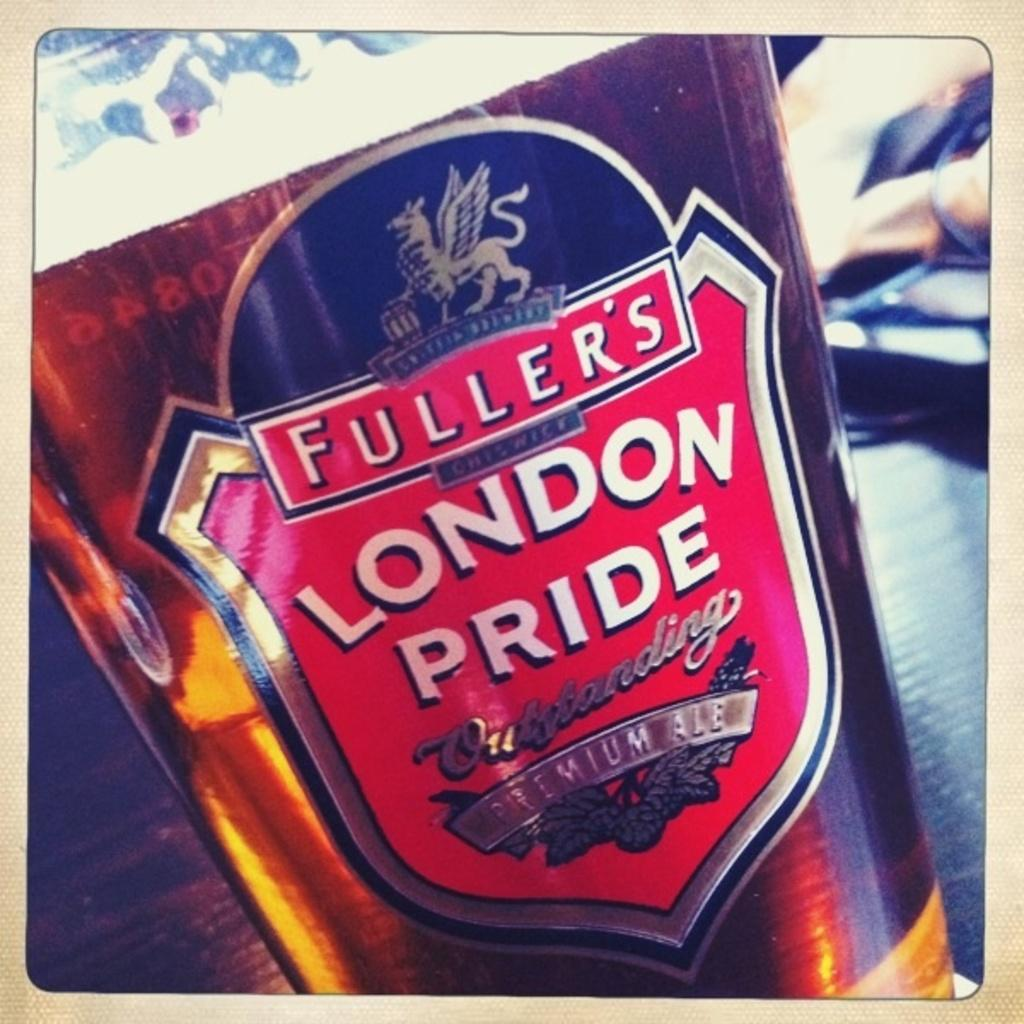What piece of furniture is present in the image? There is a table in the image. What object is placed on the table? There is a bottle on the table. How many ducks are visible on the table in the image? There are no ducks present in the image; only a table and a bottle are visible. 